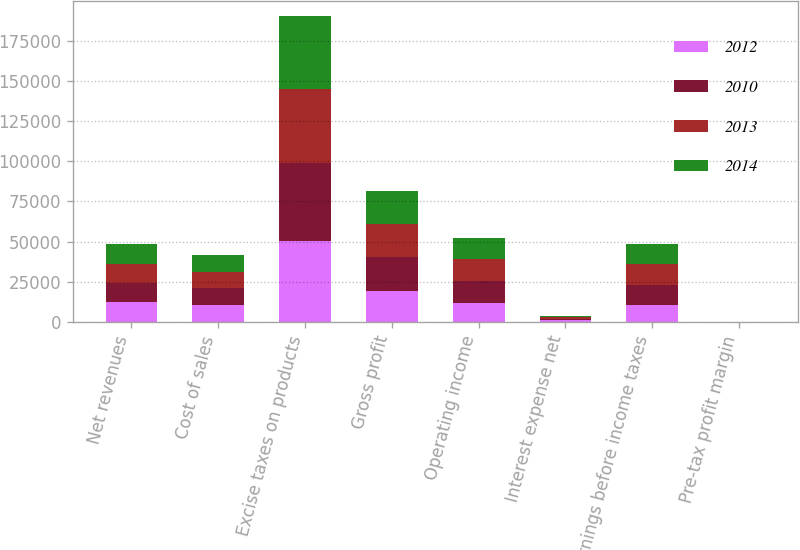Convert chart. <chart><loc_0><loc_0><loc_500><loc_500><stacked_bar_chart><ecel><fcel>Net revenues<fcel>Cost of sales<fcel>Excise taxes on products<fcel>Gross profit<fcel>Operating income<fcel>Interest expense net<fcel>Earnings before income taxes<fcel>Pre-tax profit margin<nl><fcel>2012<fcel>12122<fcel>10436<fcel>50339<fcel>19331<fcel>11702<fcel>1052<fcel>10650<fcel>13.3<nl><fcel>2010<fcel>12122<fcel>10410<fcel>48812<fcel>20807<fcel>13515<fcel>973<fcel>12542<fcel>15.7<nl><fcel>2013<fcel>12122<fcel>10373<fcel>46016<fcel>21004<fcel>13863<fcel>859<fcel>13004<fcel>16.8<nl><fcel>2014<fcel>12122<fcel>10678<fcel>45249<fcel>20419<fcel>13342<fcel>800<fcel>12542<fcel>16.4<nl></chart> 